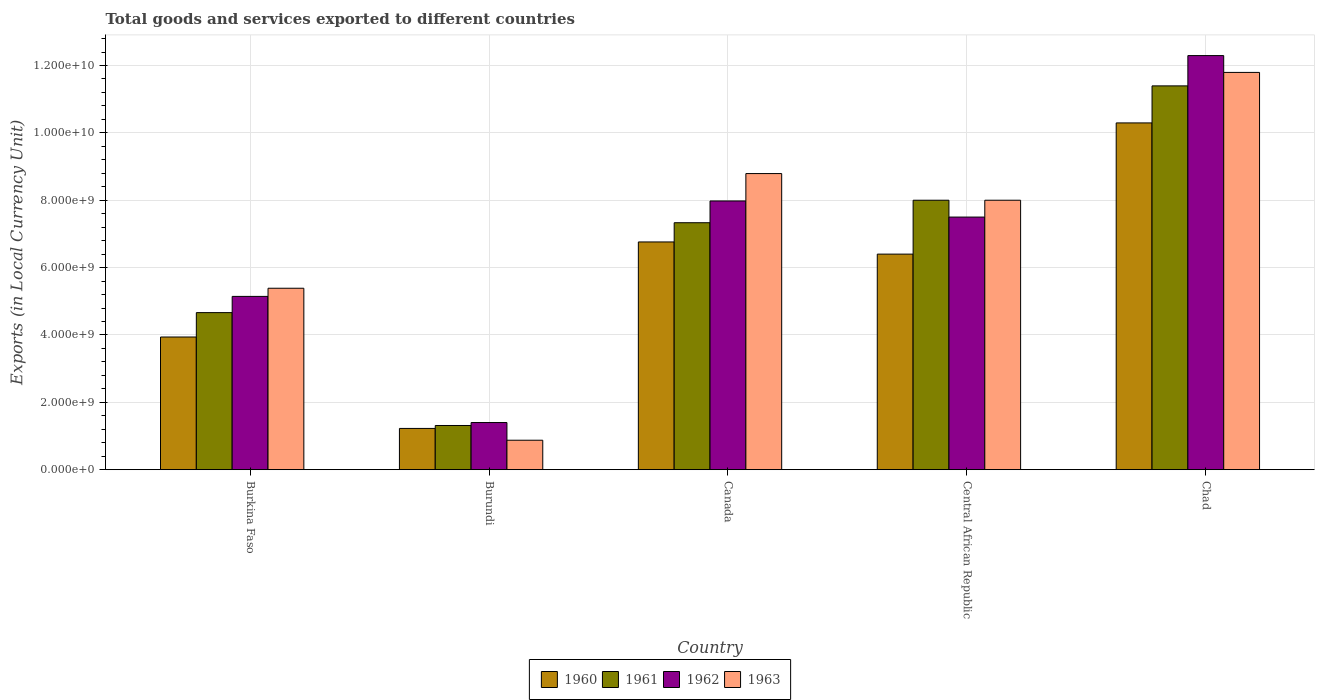How many different coloured bars are there?
Offer a very short reply. 4. Are the number of bars per tick equal to the number of legend labels?
Make the answer very short. Yes. Are the number of bars on each tick of the X-axis equal?
Keep it short and to the point. Yes. How many bars are there on the 2nd tick from the left?
Provide a succinct answer. 4. How many bars are there on the 4th tick from the right?
Your response must be concise. 4. What is the label of the 4th group of bars from the left?
Your answer should be very brief. Central African Republic. In how many cases, is the number of bars for a given country not equal to the number of legend labels?
Keep it short and to the point. 0. What is the Amount of goods and services exports in 1961 in Burkina Faso?
Give a very brief answer. 4.66e+09. Across all countries, what is the maximum Amount of goods and services exports in 1961?
Your answer should be very brief. 1.14e+1. Across all countries, what is the minimum Amount of goods and services exports in 1962?
Provide a succinct answer. 1.40e+09. In which country was the Amount of goods and services exports in 1960 maximum?
Your answer should be very brief. Chad. In which country was the Amount of goods and services exports in 1961 minimum?
Your response must be concise. Burundi. What is the total Amount of goods and services exports in 1963 in the graph?
Ensure brevity in your answer.  3.48e+1. What is the difference between the Amount of goods and services exports in 1963 in Burkina Faso and that in Central African Republic?
Provide a short and direct response. -2.61e+09. What is the difference between the Amount of goods and services exports in 1962 in Burkina Faso and the Amount of goods and services exports in 1961 in Chad?
Your answer should be very brief. -6.25e+09. What is the average Amount of goods and services exports in 1962 per country?
Your answer should be very brief. 6.86e+09. What is the difference between the Amount of goods and services exports of/in 1961 and Amount of goods and services exports of/in 1963 in Chad?
Your answer should be compact. -4.00e+08. In how many countries, is the Amount of goods and services exports in 1960 greater than 4800000000 LCU?
Your answer should be very brief. 3. What is the ratio of the Amount of goods and services exports in 1962 in Burkina Faso to that in Canada?
Keep it short and to the point. 0.64. What is the difference between the highest and the second highest Amount of goods and services exports in 1961?
Keep it short and to the point. 6.68e+08. What is the difference between the highest and the lowest Amount of goods and services exports in 1961?
Keep it short and to the point. 1.01e+1. In how many countries, is the Amount of goods and services exports in 1962 greater than the average Amount of goods and services exports in 1962 taken over all countries?
Offer a very short reply. 3. Is it the case that in every country, the sum of the Amount of goods and services exports in 1962 and Amount of goods and services exports in 1961 is greater than the sum of Amount of goods and services exports in 1960 and Amount of goods and services exports in 1963?
Provide a short and direct response. No. What does the 4th bar from the left in Burundi represents?
Your answer should be compact. 1963. How many bars are there?
Keep it short and to the point. 20. Are all the bars in the graph horizontal?
Your answer should be compact. No. What is the difference between two consecutive major ticks on the Y-axis?
Make the answer very short. 2.00e+09. Are the values on the major ticks of Y-axis written in scientific E-notation?
Your response must be concise. Yes. Does the graph contain grids?
Your answer should be compact. Yes. Where does the legend appear in the graph?
Your answer should be compact. Bottom center. How many legend labels are there?
Offer a very short reply. 4. How are the legend labels stacked?
Provide a short and direct response. Horizontal. What is the title of the graph?
Give a very brief answer. Total goods and services exported to different countries. Does "1986" appear as one of the legend labels in the graph?
Your response must be concise. No. What is the label or title of the Y-axis?
Your answer should be very brief. Exports (in Local Currency Unit). What is the Exports (in Local Currency Unit) of 1960 in Burkina Faso?
Provide a short and direct response. 3.94e+09. What is the Exports (in Local Currency Unit) in 1961 in Burkina Faso?
Your answer should be compact. 4.66e+09. What is the Exports (in Local Currency Unit) of 1962 in Burkina Faso?
Your answer should be compact. 5.14e+09. What is the Exports (in Local Currency Unit) of 1963 in Burkina Faso?
Provide a succinct answer. 5.39e+09. What is the Exports (in Local Currency Unit) of 1960 in Burundi?
Your answer should be compact. 1.22e+09. What is the Exports (in Local Currency Unit) of 1961 in Burundi?
Offer a terse response. 1.31e+09. What is the Exports (in Local Currency Unit) of 1962 in Burundi?
Your response must be concise. 1.40e+09. What is the Exports (in Local Currency Unit) in 1963 in Burundi?
Provide a succinct answer. 8.75e+08. What is the Exports (in Local Currency Unit) of 1960 in Canada?
Your answer should be very brief. 6.76e+09. What is the Exports (in Local Currency Unit) of 1961 in Canada?
Provide a succinct answer. 7.33e+09. What is the Exports (in Local Currency Unit) in 1962 in Canada?
Provide a succinct answer. 7.98e+09. What is the Exports (in Local Currency Unit) of 1963 in Canada?
Make the answer very short. 8.79e+09. What is the Exports (in Local Currency Unit) in 1960 in Central African Republic?
Provide a short and direct response. 6.40e+09. What is the Exports (in Local Currency Unit) of 1961 in Central African Republic?
Provide a succinct answer. 8.00e+09. What is the Exports (in Local Currency Unit) of 1962 in Central African Republic?
Keep it short and to the point. 7.50e+09. What is the Exports (in Local Currency Unit) of 1963 in Central African Republic?
Your answer should be very brief. 8.00e+09. What is the Exports (in Local Currency Unit) in 1960 in Chad?
Offer a terse response. 1.03e+1. What is the Exports (in Local Currency Unit) in 1961 in Chad?
Keep it short and to the point. 1.14e+1. What is the Exports (in Local Currency Unit) in 1962 in Chad?
Make the answer very short. 1.23e+1. What is the Exports (in Local Currency Unit) of 1963 in Chad?
Provide a succinct answer. 1.18e+1. Across all countries, what is the maximum Exports (in Local Currency Unit) in 1960?
Offer a very short reply. 1.03e+1. Across all countries, what is the maximum Exports (in Local Currency Unit) in 1961?
Keep it short and to the point. 1.14e+1. Across all countries, what is the maximum Exports (in Local Currency Unit) in 1962?
Offer a very short reply. 1.23e+1. Across all countries, what is the maximum Exports (in Local Currency Unit) in 1963?
Your answer should be very brief. 1.18e+1. Across all countries, what is the minimum Exports (in Local Currency Unit) in 1960?
Keep it short and to the point. 1.22e+09. Across all countries, what is the minimum Exports (in Local Currency Unit) of 1961?
Ensure brevity in your answer.  1.31e+09. Across all countries, what is the minimum Exports (in Local Currency Unit) of 1962?
Your response must be concise. 1.40e+09. Across all countries, what is the minimum Exports (in Local Currency Unit) in 1963?
Make the answer very short. 8.75e+08. What is the total Exports (in Local Currency Unit) in 1960 in the graph?
Your answer should be very brief. 2.86e+1. What is the total Exports (in Local Currency Unit) of 1961 in the graph?
Provide a short and direct response. 3.27e+1. What is the total Exports (in Local Currency Unit) of 1962 in the graph?
Your answer should be compact. 3.43e+1. What is the total Exports (in Local Currency Unit) of 1963 in the graph?
Provide a succinct answer. 3.48e+1. What is the difference between the Exports (in Local Currency Unit) of 1960 in Burkina Faso and that in Burundi?
Your answer should be compact. 2.71e+09. What is the difference between the Exports (in Local Currency Unit) of 1961 in Burkina Faso and that in Burundi?
Offer a terse response. 3.35e+09. What is the difference between the Exports (in Local Currency Unit) of 1962 in Burkina Faso and that in Burundi?
Offer a terse response. 3.74e+09. What is the difference between the Exports (in Local Currency Unit) in 1963 in Burkina Faso and that in Burundi?
Ensure brevity in your answer.  4.51e+09. What is the difference between the Exports (in Local Currency Unit) of 1960 in Burkina Faso and that in Canada?
Your answer should be very brief. -2.82e+09. What is the difference between the Exports (in Local Currency Unit) of 1961 in Burkina Faso and that in Canada?
Your answer should be very brief. -2.67e+09. What is the difference between the Exports (in Local Currency Unit) in 1962 in Burkina Faso and that in Canada?
Provide a succinct answer. -2.83e+09. What is the difference between the Exports (in Local Currency Unit) in 1963 in Burkina Faso and that in Canada?
Provide a short and direct response. -3.40e+09. What is the difference between the Exports (in Local Currency Unit) in 1960 in Burkina Faso and that in Central African Republic?
Provide a short and direct response. -2.46e+09. What is the difference between the Exports (in Local Currency Unit) in 1961 in Burkina Faso and that in Central African Republic?
Provide a succinct answer. -3.34e+09. What is the difference between the Exports (in Local Currency Unit) of 1962 in Burkina Faso and that in Central African Republic?
Provide a short and direct response. -2.36e+09. What is the difference between the Exports (in Local Currency Unit) in 1963 in Burkina Faso and that in Central African Republic?
Ensure brevity in your answer.  -2.61e+09. What is the difference between the Exports (in Local Currency Unit) of 1960 in Burkina Faso and that in Chad?
Offer a very short reply. -6.36e+09. What is the difference between the Exports (in Local Currency Unit) in 1961 in Burkina Faso and that in Chad?
Make the answer very short. -6.73e+09. What is the difference between the Exports (in Local Currency Unit) of 1962 in Burkina Faso and that in Chad?
Make the answer very short. -7.15e+09. What is the difference between the Exports (in Local Currency Unit) of 1963 in Burkina Faso and that in Chad?
Offer a terse response. -6.41e+09. What is the difference between the Exports (in Local Currency Unit) of 1960 in Burundi and that in Canada?
Provide a succinct answer. -5.54e+09. What is the difference between the Exports (in Local Currency Unit) of 1961 in Burundi and that in Canada?
Ensure brevity in your answer.  -6.02e+09. What is the difference between the Exports (in Local Currency Unit) in 1962 in Burundi and that in Canada?
Your answer should be compact. -6.58e+09. What is the difference between the Exports (in Local Currency Unit) of 1963 in Burundi and that in Canada?
Provide a succinct answer. -7.92e+09. What is the difference between the Exports (in Local Currency Unit) in 1960 in Burundi and that in Central African Republic?
Provide a short and direct response. -5.18e+09. What is the difference between the Exports (in Local Currency Unit) in 1961 in Burundi and that in Central African Republic?
Give a very brief answer. -6.69e+09. What is the difference between the Exports (in Local Currency Unit) of 1962 in Burundi and that in Central African Republic?
Your response must be concise. -6.10e+09. What is the difference between the Exports (in Local Currency Unit) in 1963 in Burundi and that in Central African Republic?
Your response must be concise. -7.12e+09. What is the difference between the Exports (in Local Currency Unit) of 1960 in Burundi and that in Chad?
Offer a terse response. -9.07e+09. What is the difference between the Exports (in Local Currency Unit) in 1961 in Burundi and that in Chad?
Provide a succinct answer. -1.01e+1. What is the difference between the Exports (in Local Currency Unit) in 1962 in Burundi and that in Chad?
Your response must be concise. -1.09e+1. What is the difference between the Exports (in Local Currency Unit) of 1963 in Burundi and that in Chad?
Your answer should be compact. -1.09e+1. What is the difference between the Exports (in Local Currency Unit) in 1960 in Canada and that in Central African Republic?
Keep it short and to the point. 3.61e+08. What is the difference between the Exports (in Local Currency Unit) in 1961 in Canada and that in Central African Republic?
Provide a succinct answer. -6.68e+08. What is the difference between the Exports (in Local Currency Unit) of 1962 in Canada and that in Central African Republic?
Give a very brief answer. 4.78e+08. What is the difference between the Exports (in Local Currency Unit) in 1963 in Canada and that in Central African Republic?
Your answer should be very brief. 7.91e+08. What is the difference between the Exports (in Local Currency Unit) of 1960 in Canada and that in Chad?
Your response must be concise. -3.53e+09. What is the difference between the Exports (in Local Currency Unit) in 1961 in Canada and that in Chad?
Offer a terse response. -4.06e+09. What is the difference between the Exports (in Local Currency Unit) of 1962 in Canada and that in Chad?
Provide a short and direct response. -4.32e+09. What is the difference between the Exports (in Local Currency Unit) of 1963 in Canada and that in Chad?
Your response must be concise. -3.00e+09. What is the difference between the Exports (in Local Currency Unit) of 1960 in Central African Republic and that in Chad?
Offer a very short reply. -3.90e+09. What is the difference between the Exports (in Local Currency Unit) of 1961 in Central African Republic and that in Chad?
Your response must be concise. -3.39e+09. What is the difference between the Exports (in Local Currency Unit) of 1962 in Central African Republic and that in Chad?
Provide a succinct answer. -4.79e+09. What is the difference between the Exports (in Local Currency Unit) in 1963 in Central African Republic and that in Chad?
Your response must be concise. -3.79e+09. What is the difference between the Exports (in Local Currency Unit) of 1960 in Burkina Faso and the Exports (in Local Currency Unit) of 1961 in Burundi?
Make the answer very short. 2.63e+09. What is the difference between the Exports (in Local Currency Unit) of 1960 in Burkina Faso and the Exports (in Local Currency Unit) of 1962 in Burundi?
Offer a terse response. 2.54e+09. What is the difference between the Exports (in Local Currency Unit) of 1960 in Burkina Faso and the Exports (in Local Currency Unit) of 1963 in Burundi?
Ensure brevity in your answer.  3.06e+09. What is the difference between the Exports (in Local Currency Unit) of 1961 in Burkina Faso and the Exports (in Local Currency Unit) of 1962 in Burundi?
Keep it short and to the point. 3.26e+09. What is the difference between the Exports (in Local Currency Unit) of 1961 in Burkina Faso and the Exports (in Local Currency Unit) of 1963 in Burundi?
Offer a very short reply. 3.79e+09. What is the difference between the Exports (in Local Currency Unit) of 1962 in Burkina Faso and the Exports (in Local Currency Unit) of 1963 in Burundi?
Give a very brief answer. 4.27e+09. What is the difference between the Exports (in Local Currency Unit) in 1960 in Burkina Faso and the Exports (in Local Currency Unit) in 1961 in Canada?
Give a very brief answer. -3.39e+09. What is the difference between the Exports (in Local Currency Unit) in 1960 in Burkina Faso and the Exports (in Local Currency Unit) in 1962 in Canada?
Make the answer very short. -4.04e+09. What is the difference between the Exports (in Local Currency Unit) in 1960 in Burkina Faso and the Exports (in Local Currency Unit) in 1963 in Canada?
Make the answer very short. -4.85e+09. What is the difference between the Exports (in Local Currency Unit) in 1961 in Burkina Faso and the Exports (in Local Currency Unit) in 1962 in Canada?
Give a very brief answer. -3.31e+09. What is the difference between the Exports (in Local Currency Unit) of 1961 in Burkina Faso and the Exports (in Local Currency Unit) of 1963 in Canada?
Offer a very short reply. -4.13e+09. What is the difference between the Exports (in Local Currency Unit) in 1962 in Burkina Faso and the Exports (in Local Currency Unit) in 1963 in Canada?
Your response must be concise. -3.65e+09. What is the difference between the Exports (in Local Currency Unit) in 1960 in Burkina Faso and the Exports (in Local Currency Unit) in 1961 in Central African Republic?
Offer a very short reply. -4.06e+09. What is the difference between the Exports (in Local Currency Unit) of 1960 in Burkina Faso and the Exports (in Local Currency Unit) of 1962 in Central African Republic?
Your answer should be very brief. -3.56e+09. What is the difference between the Exports (in Local Currency Unit) in 1960 in Burkina Faso and the Exports (in Local Currency Unit) in 1963 in Central African Republic?
Ensure brevity in your answer.  -4.06e+09. What is the difference between the Exports (in Local Currency Unit) of 1961 in Burkina Faso and the Exports (in Local Currency Unit) of 1962 in Central African Republic?
Offer a terse response. -2.84e+09. What is the difference between the Exports (in Local Currency Unit) of 1961 in Burkina Faso and the Exports (in Local Currency Unit) of 1963 in Central African Republic?
Your response must be concise. -3.34e+09. What is the difference between the Exports (in Local Currency Unit) in 1962 in Burkina Faso and the Exports (in Local Currency Unit) in 1963 in Central African Republic?
Your response must be concise. -2.86e+09. What is the difference between the Exports (in Local Currency Unit) in 1960 in Burkina Faso and the Exports (in Local Currency Unit) in 1961 in Chad?
Give a very brief answer. -7.46e+09. What is the difference between the Exports (in Local Currency Unit) of 1960 in Burkina Faso and the Exports (in Local Currency Unit) of 1962 in Chad?
Keep it short and to the point. -8.35e+09. What is the difference between the Exports (in Local Currency Unit) in 1960 in Burkina Faso and the Exports (in Local Currency Unit) in 1963 in Chad?
Provide a short and direct response. -7.86e+09. What is the difference between the Exports (in Local Currency Unit) of 1961 in Burkina Faso and the Exports (in Local Currency Unit) of 1962 in Chad?
Give a very brief answer. -7.63e+09. What is the difference between the Exports (in Local Currency Unit) of 1961 in Burkina Faso and the Exports (in Local Currency Unit) of 1963 in Chad?
Your response must be concise. -7.13e+09. What is the difference between the Exports (in Local Currency Unit) in 1962 in Burkina Faso and the Exports (in Local Currency Unit) in 1963 in Chad?
Offer a very short reply. -6.65e+09. What is the difference between the Exports (in Local Currency Unit) of 1960 in Burundi and the Exports (in Local Currency Unit) of 1961 in Canada?
Your answer should be very brief. -6.11e+09. What is the difference between the Exports (in Local Currency Unit) of 1960 in Burundi and the Exports (in Local Currency Unit) of 1962 in Canada?
Provide a succinct answer. -6.75e+09. What is the difference between the Exports (in Local Currency Unit) in 1960 in Burundi and the Exports (in Local Currency Unit) in 1963 in Canada?
Provide a succinct answer. -7.57e+09. What is the difference between the Exports (in Local Currency Unit) in 1961 in Burundi and the Exports (in Local Currency Unit) in 1962 in Canada?
Make the answer very short. -6.67e+09. What is the difference between the Exports (in Local Currency Unit) in 1961 in Burundi and the Exports (in Local Currency Unit) in 1963 in Canada?
Give a very brief answer. -7.48e+09. What is the difference between the Exports (in Local Currency Unit) in 1962 in Burundi and the Exports (in Local Currency Unit) in 1963 in Canada?
Make the answer very short. -7.39e+09. What is the difference between the Exports (in Local Currency Unit) of 1960 in Burundi and the Exports (in Local Currency Unit) of 1961 in Central African Republic?
Ensure brevity in your answer.  -6.78e+09. What is the difference between the Exports (in Local Currency Unit) in 1960 in Burundi and the Exports (in Local Currency Unit) in 1962 in Central African Republic?
Offer a very short reply. -6.28e+09. What is the difference between the Exports (in Local Currency Unit) of 1960 in Burundi and the Exports (in Local Currency Unit) of 1963 in Central African Republic?
Make the answer very short. -6.78e+09. What is the difference between the Exports (in Local Currency Unit) in 1961 in Burundi and the Exports (in Local Currency Unit) in 1962 in Central African Republic?
Provide a succinct answer. -6.19e+09. What is the difference between the Exports (in Local Currency Unit) in 1961 in Burundi and the Exports (in Local Currency Unit) in 1963 in Central African Republic?
Ensure brevity in your answer.  -6.69e+09. What is the difference between the Exports (in Local Currency Unit) in 1962 in Burundi and the Exports (in Local Currency Unit) in 1963 in Central African Republic?
Your answer should be very brief. -6.60e+09. What is the difference between the Exports (in Local Currency Unit) of 1960 in Burundi and the Exports (in Local Currency Unit) of 1961 in Chad?
Offer a very short reply. -1.02e+1. What is the difference between the Exports (in Local Currency Unit) of 1960 in Burundi and the Exports (in Local Currency Unit) of 1962 in Chad?
Provide a short and direct response. -1.11e+1. What is the difference between the Exports (in Local Currency Unit) of 1960 in Burundi and the Exports (in Local Currency Unit) of 1963 in Chad?
Ensure brevity in your answer.  -1.06e+1. What is the difference between the Exports (in Local Currency Unit) in 1961 in Burundi and the Exports (in Local Currency Unit) in 1962 in Chad?
Offer a terse response. -1.10e+1. What is the difference between the Exports (in Local Currency Unit) in 1961 in Burundi and the Exports (in Local Currency Unit) in 1963 in Chad?
Offer a very short reply. -1.05e+1. What is the difference between the Exports (in Local Currency Unit) in 1962 in Burundi and the Exports (in Local Currency Unit) in 1963 in Chad?
Provide a succinct answer. -1.04e+1. What is the difference between the Exports (in Local Currency Unit) in 1960 in Canada and the Exports (in Local Currency Unit) in 1961 in Central African Republic?
Make the answer very short. -1.24e+09. What is the difference between the Exports (in Local Currency Unit) in 1960 in Canada and the Exports (in Local Currency Unit) in 1962 in Central African Republic?
Offer a very short reply. -7.39e+08. What is the difference between the Exports (in Local Currency Unit) in 1960 in Canada and the Exports (in Local Currency Unit) in 1963 in Central African Republic?
Ensure brevity in your answer.  -1.24e+09. What is the difference between the Exports (in Local Currency Unit) of 1961 in Canada and the Exports (in Local Currency Unit) of 1962 in Central African Republic?
Your answer should be very brief. -1.68e+08. What is the difference between the Exports (in Local Currency Unit) of 1961 in Canada and the Exports (in Local Currency Unit) of 1963 in Central African Republic?
Ensure brevity in your answer.  -6.68e+08. What is the difference between the Exports (in Local Currency Unit) in 1962 in Canada and the Exports (in Local Currency Unit) in 1963 in Central African Republic?
Your response must be concise. -2.17e+07. What is the difference between the Exports (in Local Currency Unit) of 1960 in Canada and the Exports (in Local Currency Unit) of 1961 in Chad?
Ensure brevity in your answer.  -4.63e+09. What is the difference between the Exports (in Local Currency Unit) in 1960 in Canada and the Exports (in Local Currency Unit) in 1962 in Chad?
Your answer should be very brief. -5.53e+09. What is the difference between the Exports (in Local Currency Unit) of 1960 in Canada and the Exports (in Local Currency Unit) of 1963 in Chad?
Your response must be concise. -5.03e+09. What is the difference between the Exports (in Local Currency Unit) in 1961 in Canada and the Exports (in Local Currency Unit) in 1962 in Chad?
Your answer should be compact. -4.96e+09. What is the difference between the Exports (in Local Currency Unit) in 1961 in Canada and the Exports (in Local Currency Unit) in 1963 in Chad?
Make the answer very short. -4.46e+09. What is the difference between the Exports (in Local Currency Unit) in 1962 in Canada and the Exports (in Local Currency Unit) in 1963 in Chad?
Offer a terse response. -3.82e+09. What is the difference between the Exports (in Local Currency Unit) of 1960 in Central African Republic and the Exports (in Local Currency Unit) of 1961 in Chad?
Offer a terse response. -4.99e+09. What is the difference between the Exports (in Local Currency Unit) in 1960 in Central African Republic and the Exports (in Local Currency Unit) in 1962 in Chad?
Provide a succinct answer. -5.89e+09. What is the difference between the Exports (in Local Currency Unit) of 1960 in Central African Republic and the Exports (in Local Currency Unit) of 1963 in Chad?
Keep it short and to the point. -5.39e+09. What is the difference between the Exports (in Local Currency Unit) in 1961 in Central African Republic and the Exports (in Local Currency Unit) in 1962 in Chad?
Your response must be concise. -4.29e+09. What is the difference between the Exports (in Local Currency Unit) of 1961 in Central African Republic and the Exports (in Local Currency Unit) of 1963 in Chad?
Offer a terse response. -3.79e+09. What is the difference between the Exports (in Local Currency Unit) of 1962 in Central African Republic and the Exports (in Local Currency Unit) of 1963 in Chad?
Provide a succinct answer. -4.29e+09. What is the average Exports (in Local Currency Unit) of 1960 per country?
Offer a very short reply. 5.72e+09. What is the average Exports (in Local Currency Unit) of 1961 per country?
Offer a terse response. 6.54e+09. What is the average Exports (in Local Currency Unit) in 1962 per country?
Provide a short and direct response. 6.86e+09. What is the average Exports (in Local Currency Unit) of 1963 per country?
Offer a terse response. 6.97e+09. What is the difference between the Exports (in Local Currency Unit) in 1960 and Exports (in Local Currency Unit) in 1961 in Burkina Faso?
Provide a succinct answer. -7.24e+08. What is the difference between the Exports (in Local Currency Unit) in 1960 and Exports (in Local Currency Unit) in 1962 in Burkina Faso?
Provide a short and direct response. -1.21e+09. What is the difference between the Exports (in Local Currency Unit) of 1960 and Exports (in Local Currency Unit) of 1963 in Burkina Faso?
Your response must be concise. -1.45e+09. What is the difference between the Exports (in Local Currency Unit) in 1961 and Exports (in Local Currency Unit) in 1962 in Burkina Faso?
Provide a short and direct response. -4.81e+08. What is the difference between the Exports (in Local Currency Unit) in 1961 and Exports (in Local Currency Unit) in 1963 in Burkina Faso?
Your response must be concise. -7.23e+08. What is the difference between the Exports (in Local Currency Unit) in 1962 and Exports (in Local Currency Unit) in 1963 in Burkina Faso?
Offer a very short reply. -2.42e+08. What is the difference between the Exports (in Local Currency Unit) of 1960 and Exports (in Local Currency Unit) of 1961 in Burundi?
Give a very brief answer. -8.75e+07. What is the difference between the Exports (in Local Currency Unit) of 1960 and Exports (in Local Currency Unit) of 1962 in Burundi?
Provide a succinct answer. -1.75e+08. What is the difference between the Exports (in Local Currency Unit) in 1960 and Exports (in Local Currency Unit) in 1963 in Burundi?
Ensure brevity in your answer.  3.50e+08. What is the difference between the Exports (in Local Currency Unit) in 1961 and Exports (in Local Currency Unit) in 1962 in Burundi?
Keep it short and to the point. -8.75e+07. What is the difference between the Exports (in Local Currency Unit) of 1961 and Exports (in Local Currency Unit) of 1963 in Burundi?
Your answer should be very brief. 4.38e+08. What is the difference between the Exports (in Local Currency Unit) in 1962 and Exports (in Local Currency Unit) in 1963 in Burundi?
Offer a very short reply. 5.25e+08. What is the difference between the Exports (in Local Currency Unit) of 1960 and Exports (in Local Currency Unit) of 1961 in Canada?
Your answer should be very brief. -5.71e+08. What is the difference between the Exports (in Local Currency Unit) of 1960 and Exports (in Local Currency Unit) of 1962 in Canada?
Your response must be concise. -1.22e+09. What is the difference between the Exports (in Local Currency Unit) in 1960 and Exports (in Local Currency Unit) in 1963 in Canada?
Offer a terse response. -2.03e+09. What is the difference between the Exports (in Local Currency Unit) of 1961 and Exports (in Local Currency Unit) of 1962 in Canada?
Make the answer very short. -6.46e+08. What is the difference between the Exports (in Local Currency Unit) in 1961 and Exports (in Local Currency Unit) in 1963 in Canada?
Ensure brevity in your answer.  -1.46e+09. What is the difference between the Exports (in Local Currency Unit) in 1962 and Exports (in Local Currency Unit) in 1963 in Canada?
Make the answer very short. -8.13e+08. What is the difference between the Exports (in Local Currency Unit) of 1960 and Exports (in Local Currency Unit) of 1961 in Central African Republic?
Offer a very short reply. -1.60e+09. What is the difference between the Exports (in Local Currency Unit) in 1960 and Exports (in Local Currency Unit) in 1962 in Central African Republic?
Offer a very short reply. -1.10e+09. What is the difference between the Exports (in Local Currency Unit) of 1960 and Exports (in Local Currency Unit) of 1963 in Central African Republic?
Provide a short and direct response. -1.60e+09. What is the difference between the Exports (in Local Currency Unit) of 1961 and Exports (in Local Currency Unit) of 1962 in Central African Republic?
Your answer should be very brief. 5.00e+08. What is the difference between the Exports (in Local Currency Unit) of 1961 and Exports (in Local Currency Unit) of 1963 in Central African Republic?
Make the answer very short. 0. What is the difference between the Exports (in Local Currency Unit) of 1962 and Exports (in Local Currency Unit) of 1963 in Central African Republic?
Your answer should be very brief. -5.00e+08. What is the difference between the Exports (in Local Currency Unit) in 1960 and Exports (in Local Currency Unit) in 1961 in Chad?
Provide a succinct answer. -1.10e+09. What is the difference between the Exports (in Local Currency Unit) in 1960 and Exports (in Local Currency Unit) in 1962 in Chad?
Make the answer very short. -2.00e+09. What is the difference between the Exports (in Local Currency Unit) of 1960 and Exports (in Local Currency Unit) of 1963 in Chad?
Keep it short and to the point. -1.50e+09. What is the difference between the Exports (in Local Currency Unit) in 1961 and Exports (in Local Currency Unit) in 1962 in Chad?
Ensure brevity in your answer.  -9.00e+08. What is the difference between the Exports (in Local Currency Unit) in 1961 and Exports (in Local Currency Unit) in 1963 in Chad?
Your answer should be compact. -4.00e+08. What is the difference between the Exports (in Local Currency Unit) in 1962 and Exports (in Local Currency Unit) in 1963 in Chad?
Provide a short and direct response. 5.00e+08. What is the ratio of the Exports (in Local Currency Unit) in 1960 in Burkina Faso to that in Burundi?
Keep it short and to the point. 3.22. What is the ratio of the Exports (in Local Currency Unit) in 1961 in Burkina Faso to that in Burundi?
Provide a succinct answer. 3.55. What is the ratio of the Exports (in Local Currency Unit) of 1962 in Burkina Faso to that in Burundi?
Provide a short and direct response. 3.67. What is the ratio of the Exports (in Local Currency Unit) of 1963 in Burkina Faso to that in Burundi?
Keep it short and to the point. 6.16. What is the ratio of the Exports (in Local Currency Unit) in 1960 in Burkina Faso to that in Canada?
Give a very brief answer. 0.58. What is the ratio of the Exports (in Local Currency Unit) of 1961 in Burkina Faso to that in Canada?
Offer a terse response. 0.64. What is the ratio of the Exports (in Local Currency Unit) in 1962 in Burkina Faso to that in Canada?
Provide a short and direct response. 0.64. What is the ratio of the Exports (in Local Currency Unit) in 1963 in Burkina Faso to that in Canada?
Offer a terse response. 0.61. What is the ratio of the Exports (in Local Currency Unit) of 1960 in Burkina Faso to that in Central African Republic?
Your answer should be compact. 0.62. What is the ratio of the Exports (in Local Currency Unit) in 1961 in Burkina Faso to that in Central African Republic?
Make the answer very short. 0.58. What is the ratio of the Exports (in Local Currency Unit) in 1962 in Burkina Faso to that in Central African Republic?
Your answer should be very brief. 0.69. What is the ratio of the Exports (in Local Currency Unit) in 1963 in Burkina Faso to that in Central African Republic?
Offer a terse response. 0.67. What is the ratio of the Exports (in Local Currency Unit) in 1960 in Burkina Faso to that in Chad?
Offer a very short reply. 0.38. What is the ratio of the Exports (in Local Currency Unit) in 1961 in Burkina Faso to that in Chad?
Offer a very short reply. 0.41. What is the ratio of the Exports (in Local Currency Unit) in 1962 in Burkina Faso to that in Chad?
Your response must be concise. 0.42. What is the ratio of the Exports (in Local Currency Unit) of 1963 in Burkina Faso to that in Chad?
Give a very brief answer. 0.46. What is the ratio of the Exports (in Local Currency Unit) of 1960 in Burundi to that in Canada?
Provide a succinct answer. 0.18. What is the ratio of the Exports (in Local Currency Unit) in 1961 in Burundi to that in Canada?
Keep it short and to the point. 0.18. What is the ratio of the Exports (in Local Currency Unit) in 1962 in Burundi to that in Canada?
Your answer should be very brief. 0.18. What is the ratio of the Exports (in Local Currency Unit) of 1963 in Burundi to that in Canada?
Provide a short and direct response. 0.1. What is the ratio of the Exports (in Local Currency Unit) of 1960 in Burundi to that in Central African Republic?
Give a very brief answer. 0.19. What is the ratio of the Exports (in Local Currency Unit) of 1961 in Burundi to that in Central African Republic?
Your answer should be compact. 0.16. What is the ratio of the Exports (in Local Currency Unit) of 1962 in Burundi to that in Central African Republic?
Your answer should be compact. 0.19. What is the ratio of the Exports (in Local Currency Unit) in 1963 in Burundi to that in Central African Republic?
Keep it short and to the point. 0.11. What is the ratio of the Exports (in Local Currency Unit) of 1960 in Burundi to that in Chad?
Provide a short and direct response. 0.12. What is the ratio of the Exports (in Local Currency Unit) of 1961 in Burundi to that in Chad?
Your answer should be compact. 0.12. What is the ratio of the Exports (in Local Currency Unit) in 1962 in Burundi to that in Chad?
Provide a succinct answer. 0.11. What is the ratio of the Exports (in Local Currency Unit) in 1963 in Burundi to that in Chad?
Your answer should be compact. 0.07. What is the ratio of the Exports (in Local Currency Unit) in 1960 in Canada to that in Central African Republic?
Offer a very short reply. 1.06. What is the ratio of the Exports (in Local Currency Unit) in 1961 in Canada to that in Central African Republic?
Provide a short and direct response. 0.92. What is the ratio of the Exports (in Local Currency Unit) of 1962 in Canada to that in Central African Republic?
Your answer should be very brief. 1.06. What is the ratio of the Exports (in Local Currency Unit) of 1963 in Canada to that in Central African Republic?
Provide a short and direct response. 1.1. What is the ratio of the Exports (in Local Currency Unit) of 1960 in Canada to that in Chad?
Offer a very short reply. 0.66. What is the ratio of the Exports (in Local Currency Unit) in 1961 in Canada to that in Chad?
Your answer should be compact. 0.64. What is the ratio of the Exports (in Local Currency Unit) of 1962 in Canada to that in Chad?
Keep it short and to the point. 0.65. What is the ratio of the Exports (in Local Currency Unit) of 1963 in Canada to that in Chad?
Your response must be concise. 0.75. What is the ratio of the Exports (in Local Currency Unit) of 1960 in Central African Republic to that in Chad?
Your response must be concise. 0.62. What is the ratio of the Exports (in Local Currency Unit) of 1961 in Central African Republic to that in Chad?
Provide a succinct answer. 0.7. What is the ratio of the Exports (in Local Currency Unit) in 1962 in Central African Republic to that in Chad?
Provide a succinct answer. 0.61. What is the ratio of the Exports (in Local Currency Unit) of 1963 in Central African Republic to that in Chad?
Keep it short and to the point. 0.68. What is the difference between the highest and the second highest Exports (in Local Currency Unit) in 1960?
Provide a short and direct response. 3.53e+09. What is the difference between the highest and the second highest Exports (in Local Currency Unit) in 1961?
Give a very brief answer. 3.39e+09. What is the difference between the highest and the second highest Exports (in Local Currency Unit) in 1962?
Ensure brevity in your answer.  4.32e+09. What is the difference between the highest and the second highest Exports (in Local Currency Unit) of 1963?
Offer a terse response. 3.00e+09. What is the difference between the highest and the lowest Exports (in Local Currency Unit) of 1960?
Your answer should be very brief. 9.07e+09. What is the difference between the highest and the lowest Exports (in Local Currency Unit) of 1961?
Provide a short and direct response. 1.01e+1. What is the difference between the highest and the lowest Exports (in Local Currency Unit) in 1962?
Your response must be concise. 1.09e+1. What is the difference between the highest and the lowest Exports (in Local Currency Unit) in 1963?
Your answer should be very brief. 1.09e+1. 